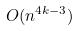<formula> <loc_0><loc_0><loc_500><loc_500>O ( n ^ { 4 k - 3 } )</formula> 